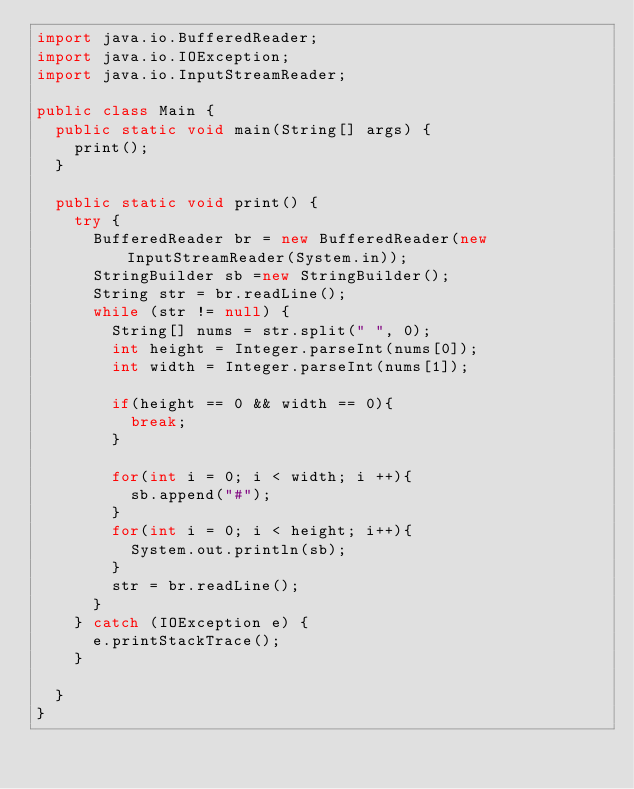<code> <loc_0><loc_0><loc_500><loc_500><_Java_>import java.io.BufferedReader;
import java.io.IOException;
import java.io.InputStreamReader;

public class Main {
	public static void main(String[] args) {
		print();
	}

	public static void print() {
		try {
			BufferedReader br = new BufferedReader(new InputStreamReader(System.in));
			StringBuilder sb =new StringBuilder();
			String str = br.readLine();
			while (str != null) {
				String[] nums = str.split(" ", 0);
				int height = Integer.parseInt(nums[0]);
				int width = Integer.parseInt(nums[1]);

				if(height == 0 && width == 0){
					break;
				}

				for(int i = 0; i < width; i ++){
					sb.append("#");
				}
				for(int i = 0; i < height; i++){
					System.out.println(sb);
				}
				str = br.readLine();
			}
		} catch (IOException e) {
			e.printStackTrace();
		}

	}
}</code> 